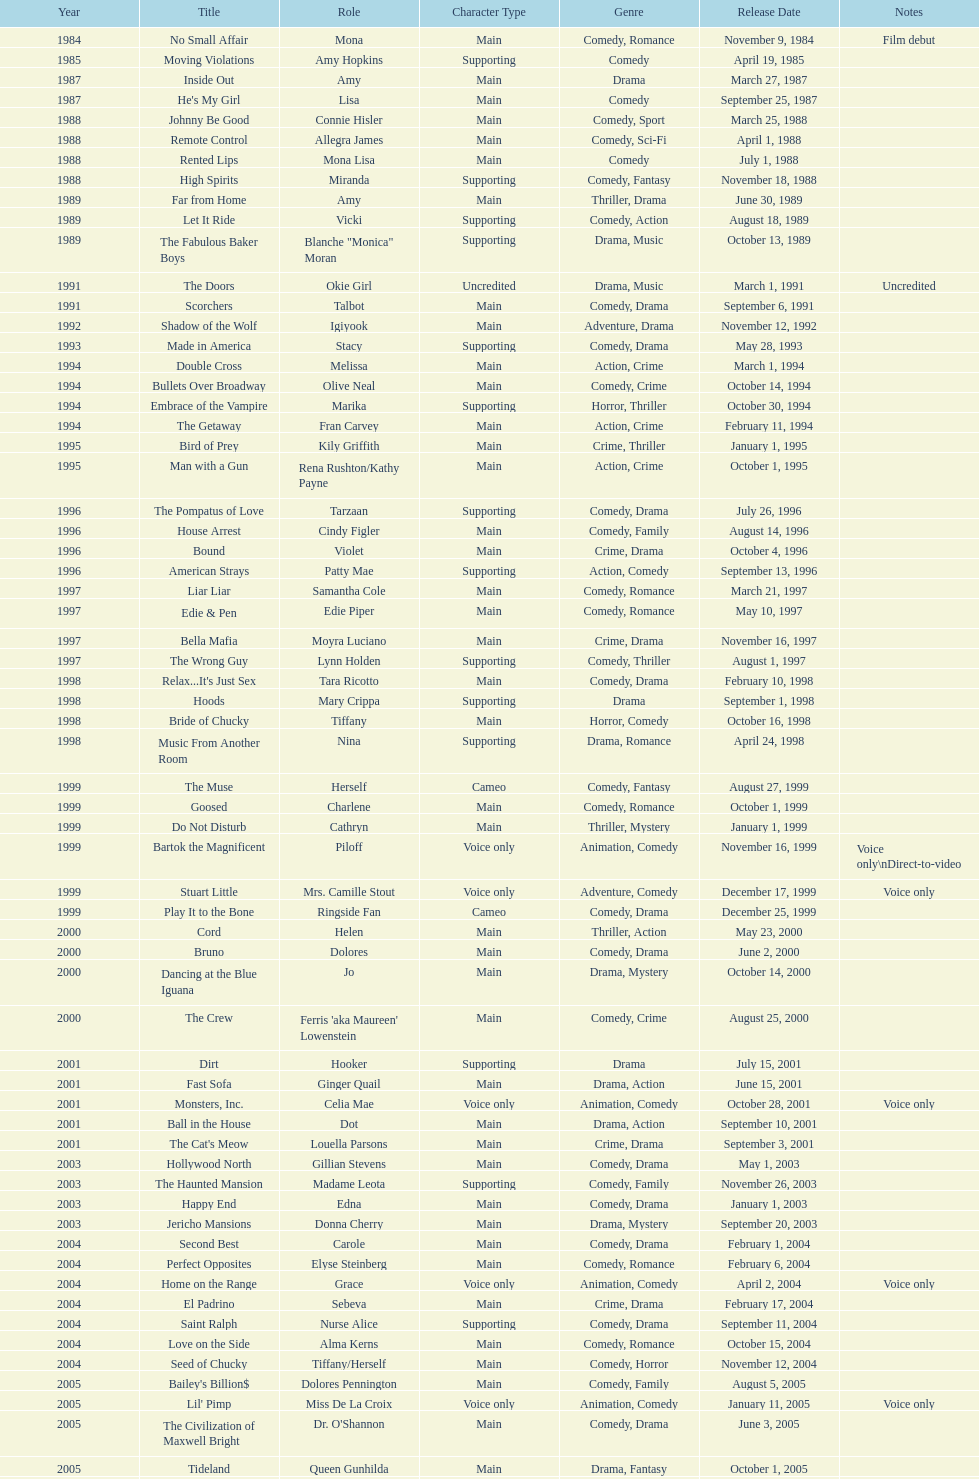Which film aired in 1994 and has marika as the role? Embrace of the Vampire. 